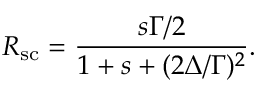<formula> <loc_0><loc_0><loc_500><loc_500>R _ { s c } = \frac { s \Gamma / 2 } { 1 + s + ( 2 \Delta / \Gamma ) ^ { 2 } } .</formula> 